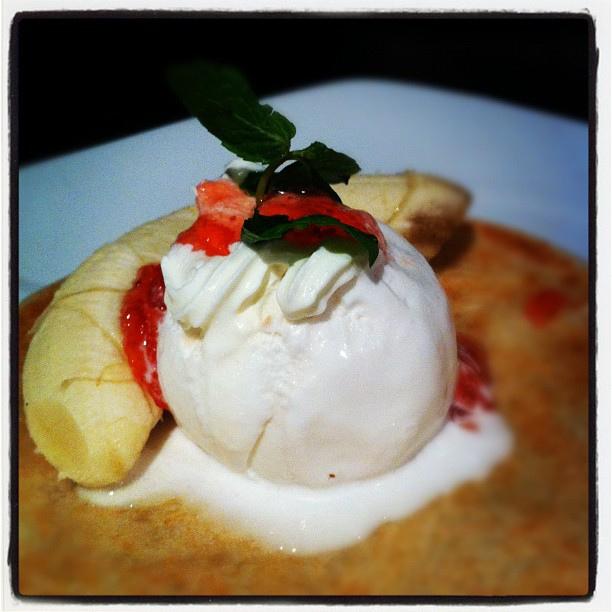What type of fruit is on top of the ice cream?
Write a very short answer. Strawberry. What is on the plate?
Give a very brief answer. Dessert. Is this a baked banana?
Keep it brief. No. 